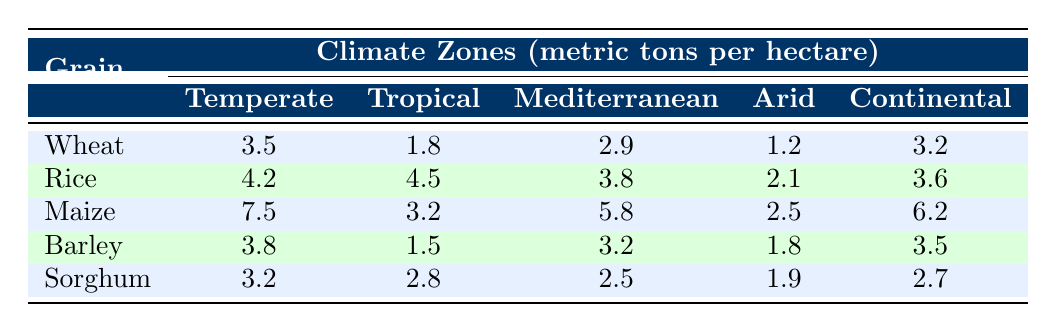What is the highest yield of maize and in which climate zone does it occur? The highest yield of maize is 7.5 metric tons per hectare, which is found in the Temperate climate zone. This value can be identified in the row for maize under the Temperate column.
Answer: 7.5 metric tons per hectare in the Temperate zone Which cereal grain has the lowest yield in the Arid climate zone? By examining the yield data for the Arid climate zone, the lowest yield corresponds to wheat at 1.2 metric tons per hectare. This is the smallest value in the Arid column across all the grains listed.
Answer: Wheat, 1.2 metric tons per hectare What is the average yield of rice across all climate zones? To find the average yield of rice, sum the yields for rice in each climate zone: (4.2 + 4.5 + 3.8 + 2.1 + 3.6) = 18.2 metric tons. Then divide by the number of climate zones (5): 18.2 / 5 = 3.64 metric tons per hectare.
Answer: 3.64 metric tons per hectare Is the yield of sorghum higher in the Tropical zone compared to the Arid zone? The yield of sorghum in the Tropical zone is 2.8 metric tons per hectare, while in the Arid zone it is 1.9 metric tons per hectare. Since 2.8 is greater than 1.9, the yield is higher in the Tropical zone.
Answer: Yes What is the difference in yield between the highest yielding grain and the lowest yielding grain in the Tropical climate zone? In the Tropical climate zone, the highest yielding grain is rice at 4.5 metric tons per hectare, and the lowest yield is barley at 1.5 metric tons per hectare. The difference can be calculated as 4.5 - 1.5 = 3.0 metric tons per hectare.
Answer: 3.0 metric tons per hectare Which climate zone has the highest average yield across all cereal grains evaluated? The yields for each climate zone can be averaged: Temperate (3.5 + 4.2 + 7.5 + 3.8 + 3.2)/5 = 4.24, Tropical (1.8 + 4.5 + 3.2 + 1.5 + 2.8)/5 = 2.76, Mediterranean (2.9 + 3.8 + 5.8 + 3.2 + 2.5)/5 = 3.84, Arid (1.2 + 2.1 + 2.5 + 1.8 + 1.9)/5 = 1.9, Continental (3.2 + 3.6 + 6.2 + 3.5 + 2.7)/5 = 3.84. The highest average yield occurs in the Temperate zone at 4.24 metric tons per hectare.
Answer: Temperate zone 